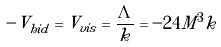<formula> <loc_0><loc_0><loc_500><loc_500>- V _ { h i d } = V _ { v i s } = \frac { \Lambda } { k } = - 2 4 M ^ { 3 } k</formula> 